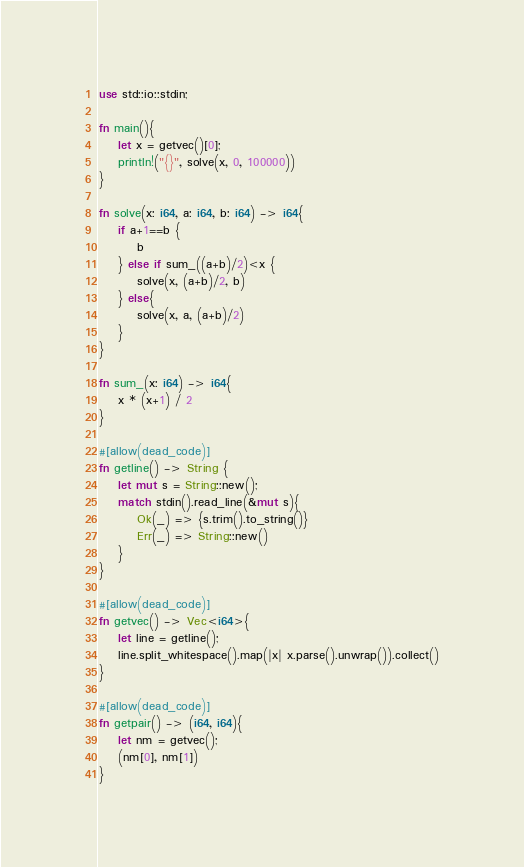Convert code to text. <code><loc_0><loc_0><loc_500><loc_500><_Rust_>use std::io::stdin;

fn main(){
    let x = getvec()[0];
    println!("{}", solve(x, 0, 100000))
}

fn solve(x: i64, a: i64, b: i64) -> i64{
    if a+1==b {
        b
    } else if sum_((a+b)/2)<x {
        solve(x, (a+b)/2, b)
    } else{
        solve(x, a, (a+b)/2)
    }
}

fn sum_(x: i64) -> i64{
    x * (x+1) / 2
}

#[allow(dead_code)]
fn getline() -> String {
    let mut s = String::new();
    match stdin().read_line(&mut s){
        Ok(_) => {s.trim().to_string()}
        Err(_) => String::new()
    }
}

#[allow(dead_code)]
fn getvec() -> Vec<i64>{
    let line = getline();
    line.split_whitespace().map(|x| x.parse().unwrap()).collect()
}

#[allow(dead_code)]
fn getpair() -> (i64, i64){
    let nm = getvec();
    (nm[0], nm[1])
}</code> 